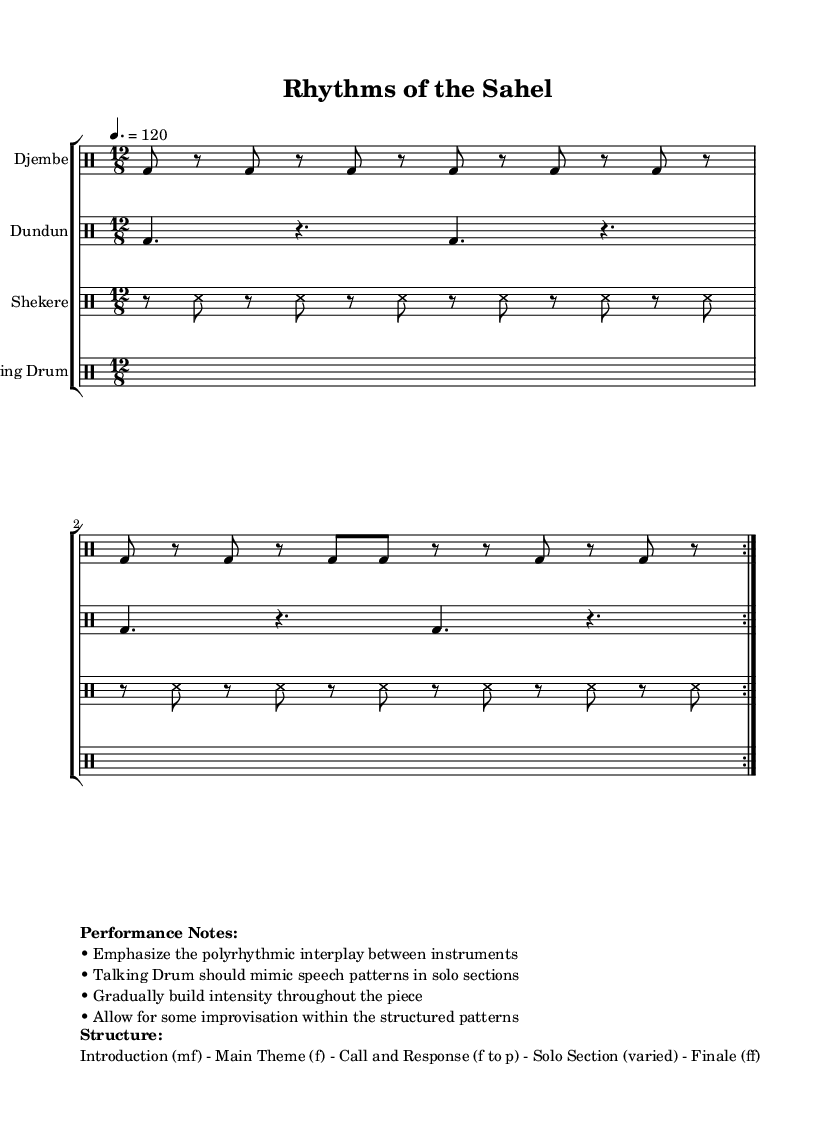What is the time signature of this music? The time signature is indicated at the beginning of the music, shown as 12/8, meaning there are twelve eighth notes in each measure.
Answer: 12/8 What is the tempo marking of this piece? The tempo marking is provided in the global section, shown as “4. = 120”, meaning the quarter note is to be played at 120 beats per minute.
Answer: 120 How many instruments are included in this ensemble? By observing the score, you can identify four distinct instruments: Djembe, Dundun, Shekere, and Talking Drum.
Answer: Four Which instrument is indicated to mimic speech patterns? In the performance notes, it specifies that the Talking Drum should mimic speech patterns during solo sections.
Answer: Talking Drum What is the dynamic marking for the main theme section? The structure of the piece indicates that the main theme should be played at a forte dynamic level, as indicated by the “f” marking.
Answer: Forte In what part of the structure does improvisation occur? The performance notes and structure indicate that improvisation should take place during the Solo Section, allowing for variation within the patterns.
Answer: Solo Section What should be emphasized during the performance? The performance notes emphasize the importance of the polyrhythmic interplay among instruments, highlighting their interaction.
Answer: Polyrhythmic interplay 